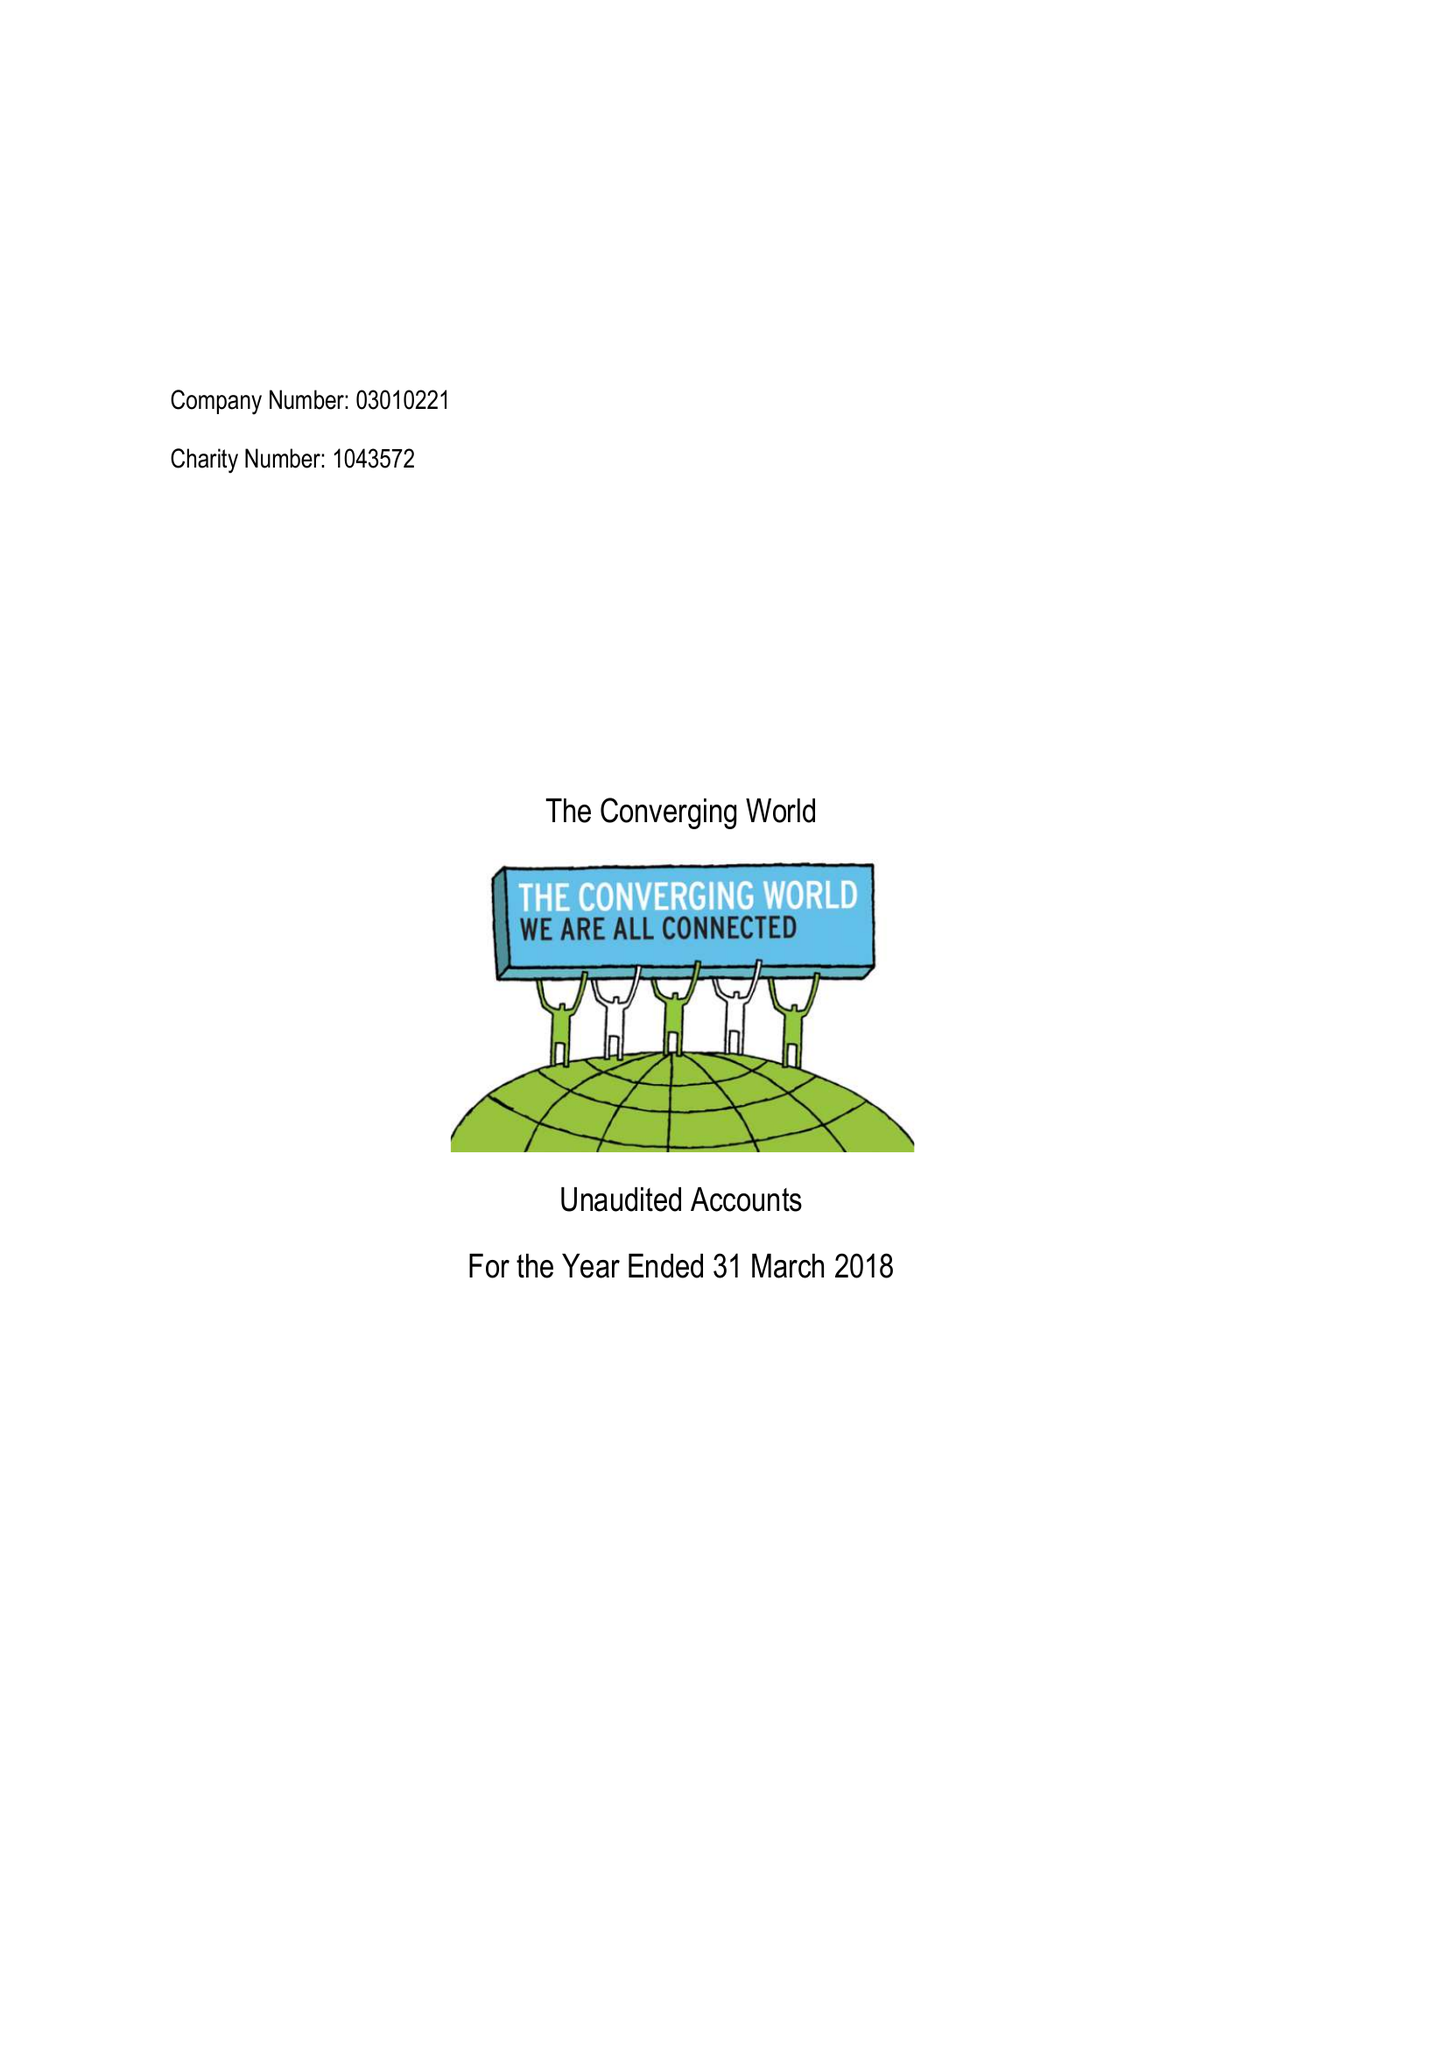What is the value for the report_date?
Answer the question using a single word or phrase. 2018-03-31 